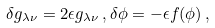Convert formula to latex. <formula><loc_0><loc_0><loc_500><loc_500>\delta g _ { \lambda \nu } = 2 \epsilon g _ { \lambda \nu } \, , \delta \phi = - \epsilon f ( \phi ) \, ,</formula> 